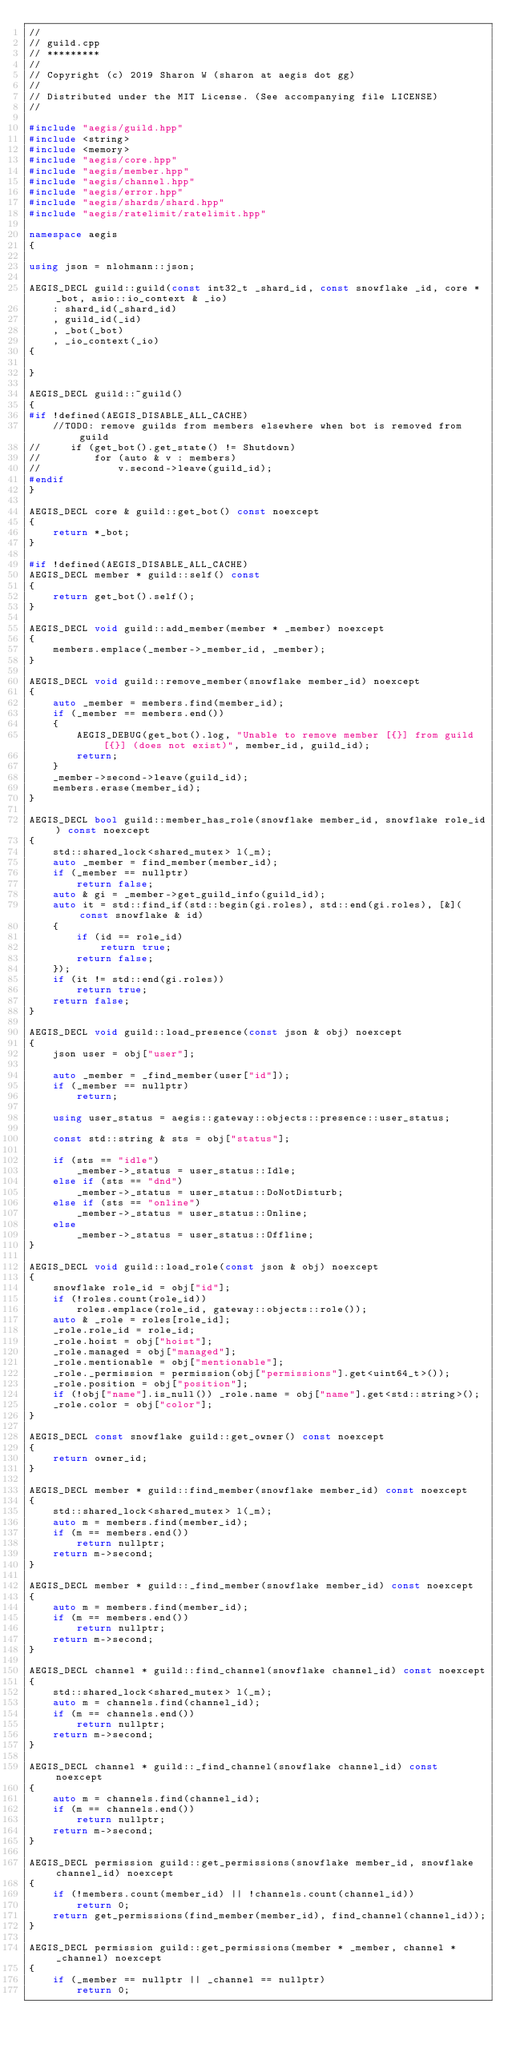<code> <loc_0><loc_0><loc_500><loc_500><_C++_>//
// guild.cpp
// *********
//
// Copyright (c) 2019 Sharon W (sharon at aegis dot gg)
//
// Distributed under the MIT License. (See accompanying file LICENSE)
//

#include "aegis/guild.hpp"
#include <string>
#include <memory>
#include "aegis/core.hpp"
#include "aegis/member.hpp"
#include "aegis/channel.hpp"
#include "aegis/error.hpp"
#include "aegis/shards/shard.hpp"
#include "aegis/ratelimit/ratelimit.hpp"

namespace aegis
{

using json = nlohmann::json;

AEGIS_DECL guild::guild(const int32_t _shard_id, const snowflake _id, core * _bot, asio::io_context & _io)
    : shard_id(_shard_id)
    , guild_id(_id)
    , _bot(_bot)
    , _io_context(_io)
{

}

AEGIS_DECL guild::~guild()
{
#if !defined(AEGIS_DISABLE_ALL_CACHE)
    //TODO: remove guilds from members elsewhere when bot is removed from guild
//     if (get_bot().get_state() != Shutdown)
//         for (auto & v : members)
//             v.second->leave(guild_id);
#endif
}

AEGIS_DECL core & guild::get_bot() const noexcept
{
    return *_bot;
}

#if !defined(AEGIS_DISABLE_ALL_CACHE)
AEGIS_DECL member * guild::self() const
{
    return get_bot().self();
}

AEGIS_DECL void guild::add_member(member * _member) noexcept
{
    members.emplace(_member->_member_id, _member);
}

AEGIS_DECL void guild::remove_member(snowflake member_id) noexcept
{
    auto _member = members.find(member_id);
    if (_member == members.end())
    {
        AEGIS_DEBUG(get_bot().log, "Unable to remove member [{}] from guild [{}] (does not exist)", member_id, guild_id);
        return;
    }
    _member->second->leave(guild_id);
    members.erase(member_id);
}

AEGIS_DECL bool guild::member_has_role(snowflake member_id, snowflake role_id) const noexcept
{
    std::shared_lock<shared_mutex> l(_m);
    auto _member = find_member(member_id);
    if (_member == nullptr)
        return false;
    auto & gi = _member->get_guild_info(guild_id);
    auto it = std::find_if(std::begin(gi.roles), std::end(gi.roles), [&](const snowflake & id)
    {
        if (id == role_id)
            return true;
        return false;
    });
    if (it != std::end(gi.roles))
        return true;
    return false;
}

AEGIS_DECL void guild::load_presence(const json & obj) noexcept
{
    json user = obj["user"];

    auto _member = _find_member(user["id"]);
    if (_member == nullptr)
        return;

    using user_status = aegis::gateway::objects::presence::user_status;

    const std::string & sts = obj["status"];

    if (sts == "idle")
        _member->_status = user_status::Idle;
    else if (sts == "dnd")
        _member->_status = user_status::DoNotDisturb;
    else if (sts == "online")
        _member->_status = user_status::Online;
    else
        _member->_status = user_status::Offline;
}

AEGIS_DECL void guild::load_role(const json & obj) noexcept
{
    snowflake role_id = obj["id"];
    if (!roles.count(role_id))
        roles.emplace(role_id, gateway::objects::role());
    auto & _role = roles[role_id];
    _role.role_id = role_id;
    _role.hoist = obj["hoist"];
    _role.managed = obj["managed"];
    _role.mentionable = obj["mentionable"];
    _role._permission = permission(obj["permissions"].get<uint64_t>());
    _role.position = obj["position"];
    if (!obj["name"].is_null()) _role.name = obj["name"].get<std::string>();
    _role.color = obj["color"];
}

AEGIS_DECL const snowflake guild::get_owner() const noexcept
{
    return owner_id;
}

AEGIS_DECL member * guild::find_member(snowflake member_id) const noexcept
{
    std::shared_lock<shared_mutex> l(_m);
    auto m = members.find(member_id);
    if (m == members.end())
        return nullptr;
    return m->second;
}

AEGIS_DECL member * guild::_find_member(snowflake member_id) const noexcept
{
    auto m = members.find(member_id);
    if (m == members.end())
        return nullptr;
    return m->second;
}

AEGIS_DECL channel * guild::find_channel(snowflake channel_id) const noexcept
{
    std::shared_lock<shared_mutex> l(_m);
    auto m = channels.find(channel_id);
    if (m == channels.end())
        return nullptr;
    return m->second;
}

AEGIS_DECL channel * guild::_find_channel(snowflake channel_id) const noexcept
{
    auto m = channels.find(channel_id);
    if (m == channels.end())
        return nullptr;
    return m->second;
}

AEGIS_DECL permission guild::get_permissions(snowflake member_id, snowflake channel_id) noexcept
{
    if (!members.count(member_id) || !channels.count(channel_id))
        return 0;
    return get_permissions(find_member(member_id), find_channel(channel_id));
}

AEGIS_DECL permission guild::get_permissions(member * _member, channel * _channel) noexcept
{
    if (_member == nullptr || _channel == nullptr)
        return 0;
</code> 